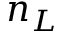Convert formula to latex. <formula><loc_0><loc_0><loc_500><loc_500>n _ { L }</formula> 